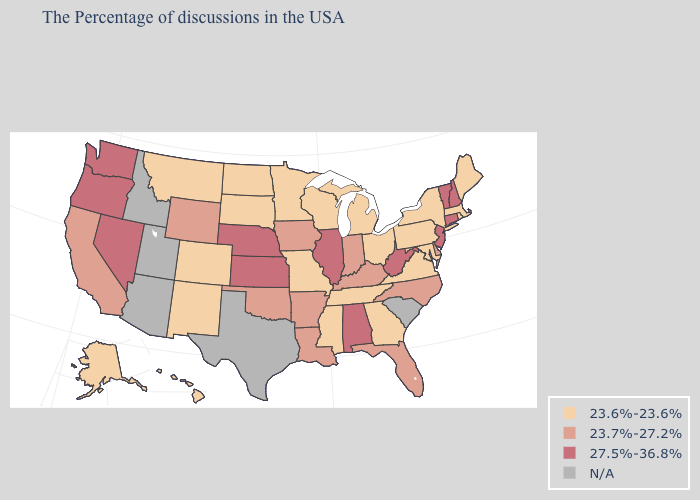Does the first symbol in the legend represent the smallest category?
Keep it brief. Yes. Name the states that have a value in the range 23.6%-23.6%?
Quick response, please. Maine, Massachusetts, Rhode Island, New York, Maryland, Pennsylvania, Virginia, Ohio, Georgia, Michigan, Tennessee, Wisconsin, Mississippi, Missouri, Minnesota, South Dakota, North Dakota, Colorado, New Mexico, Montana, Alaska, Hawaii. Name the states that have a value in the range 23.6%-23.6%?
Give a very brief answer. Maine, Massachusetts, Rhode Island, New York, Maryland, Pennsylvania, Virginia, Ohio, Georgia, Michigan, Tennessee, Wisconsin, Mississippi, Missouri, Minnesota, South Dakota, North Dakota, Colorado, New Mexico, Montana, Alaska, Hawaii. Name the states that have a value in the range 23.6%-23.6%?
Quick response, please. Maine, Massachusetts, Rhode Island, New York, Maryland, Pennsylvania, Virginia, Ohio, Georgia, Michigan, Tennessee, Wisconsin, Mississippi, Missouri, Minnesota, South Dakota, North Dakota, Colorado, New Mexico, Montana, Alaska, Hawaii. What is the highest value in the Northeast ?
Be succinct. 27.5%-36.8%. Does the first symbol in the legend represent the smallest category?
Give a very brief answer. Yes. Does the map have missing data?
Answer briefly. Yes. What is the highest value in the South ?
Give a very brief answer. 27.5%-36.8%. Name the states that have a value in the range N/A?
Concise answer only. South Carolina, Texas, Utah, Arizona, Idaho. Name the states that have a value in the range 27.5%-36.8%?
Write a very short answer. New Hampshire, Vermont, Connecticut, New Jersey, West Virginia, Alabama, Illinois, Kansas, Nebraska, Nevada, Washington, Oregon. Name the states that have a value in the range 27.5%-36.8%?
Keep it brief. New Hampshire, Vermont, Connecticut, New Jersey, West Virginia, Alabama, Illinois, Kansas, Nebraska, Nevada, Washington, Oregon. Name the states that have a value in the range 23.7%-27.2%?
Concise answer only. Delaware, North Carolina, Florida, Kentucky, Indiana, Louisiana, Arkansas, Iowa, Oklahoma, Wyoming, California. What is the lowest value in the USA?
Concise answer only. 23.6%-23.6%. 